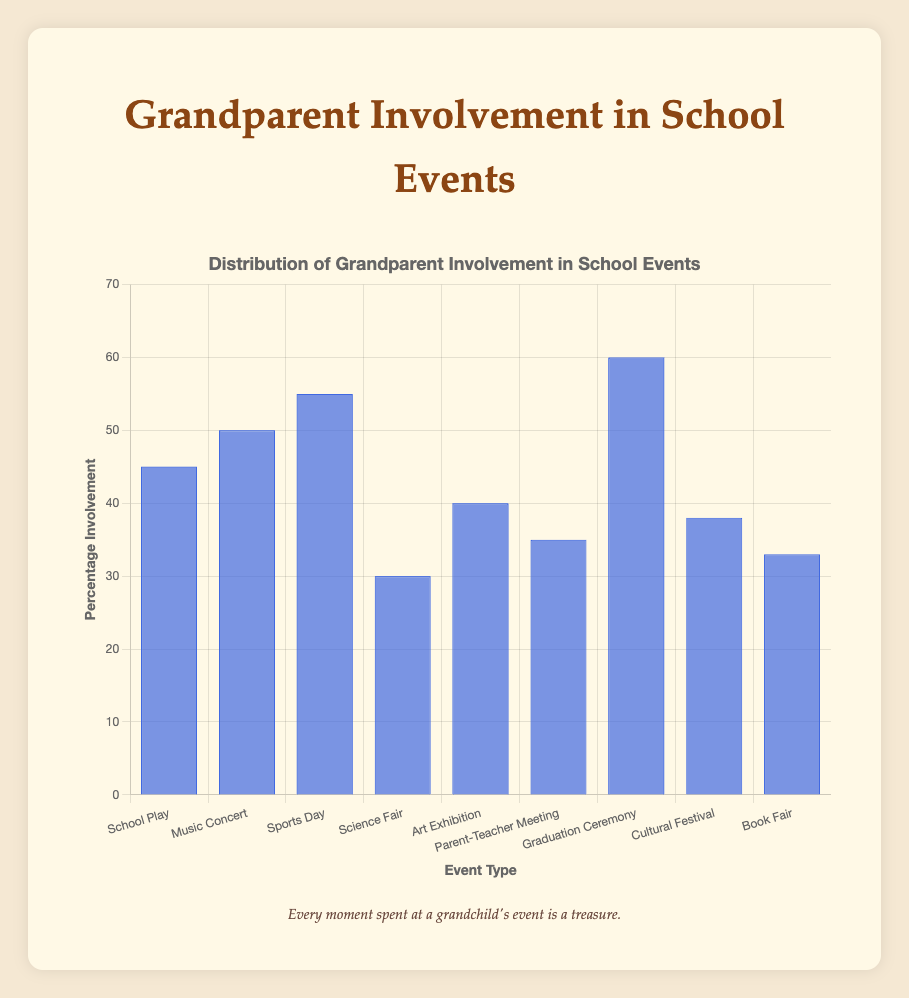What percentage of grandparents attended the Science Fair? The y-axis shows the percentage involvement for each event, and from the bar height, you can see the value associated with the Science Fair.
Answer: 30% Which event had the highest grandparent involvement? By comparing the heights of all the bars, the event with the tallest bar represents the highest involvement. The Graduation Ceremony has the tallest bar.
Answer: Graduation Ceremony Compare the grandparent involvement in the Music Concert and Parent-Teacher Meeting. Which one has higher involvement? Looking at the heights of the bars for the Music Concert and Parent-Teacher Meeting, the bar for Music Concert is higher.
Answer: Music Concert What is the difference in percentage involvement between the Sports Day and the Art Exhibition? Subtract the percentage involvement for the Art Exhibition from that for Sports Day: 55% (Sports Day) - 40% (Art Exhibition) = 15%.
Answer: 15% What is the average percentage involvement across all the events? Add up all the percentages and divide by the number of events: (45 + 50 + 55 + 30 + 40 + 35 + 60 + 38 + 33) / 9 = 42.88%.
Answer: 42.88% Which event type had the least grandparent involvement? Find the shortest bar on the chart. The bar for the Science Fair is the shortest.
Answer: Science Fair Is the percentage involvement in the Book Fair greater than that in the Cultural Festival? Compare the heights of the bars for Book Fair and Cultural Festival. The bar for Cultural Festival is higher.
Answer: No What is the combined percentage involvement for the events related to arts (School Play, Music Concert, Art Exhibition)? Sum the percentages for School Play, Music Concert, and Art Exhibition: 45% + 50% + 40% = 135%.
Answer: 135% How many events have a grandparent involvement of over 40%? Count the bars that exceed the 40% mark. There are five bars: School Play, Music Concert, Sports Day, Art Exhibition, and Graduation Ceremony.
Answer: 5 